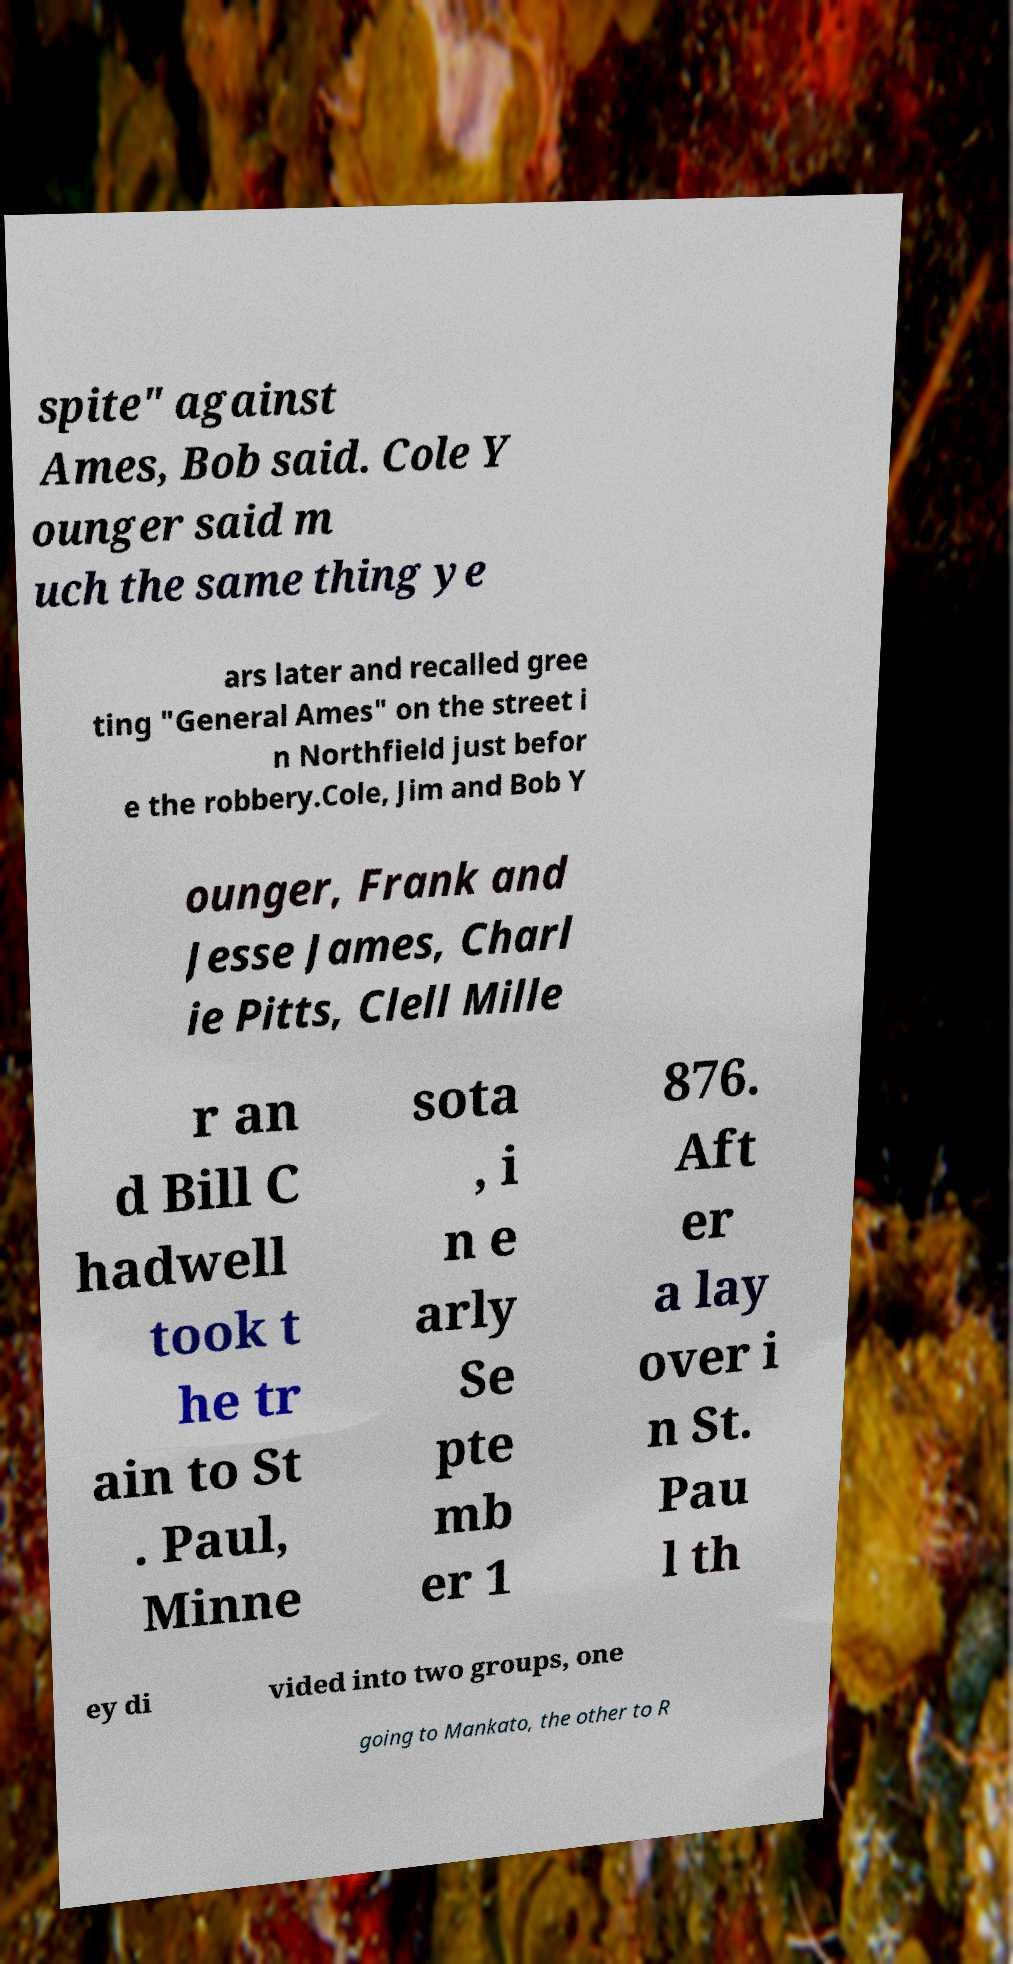I need the written content from this picture converted into text. Can you do that? spite" against Ames, Bob said. Cole Y ounger said m uch the same thing ye ars later and recalled gree ting "General Ames" on the street i n Northfield just befor e the robbery.Cole, Jim and Bob Y ounger, Frank and Jesse James, Charl ie Pitts, Clell Mille r an d Bill C hadwell took t he tr ain to St . Paul, Minne sota , i n e arly Se pte mb er 1 876. Aft er a lay over i n St. Pau l th ey di vided into two groups, one going to Mankato, the other to R 